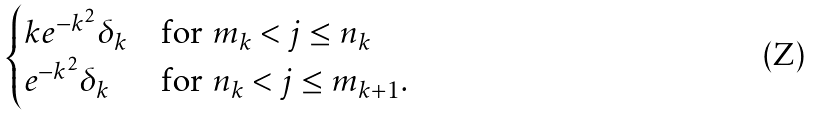Convert formula to latex. <formula><loc_0><loc_0><loc_500><loc_500>\begin{cases} k e ^ { - k ^ { 2 } } \delta _ { k } & \text {for $m_{k} < j \leq n_{k}$} \\ e ^ { - k ^ { 2 } } \delta _ { k } & \text {for $n_{k} < j \leq m_{k+1}.$} \end{cases}</formula> 